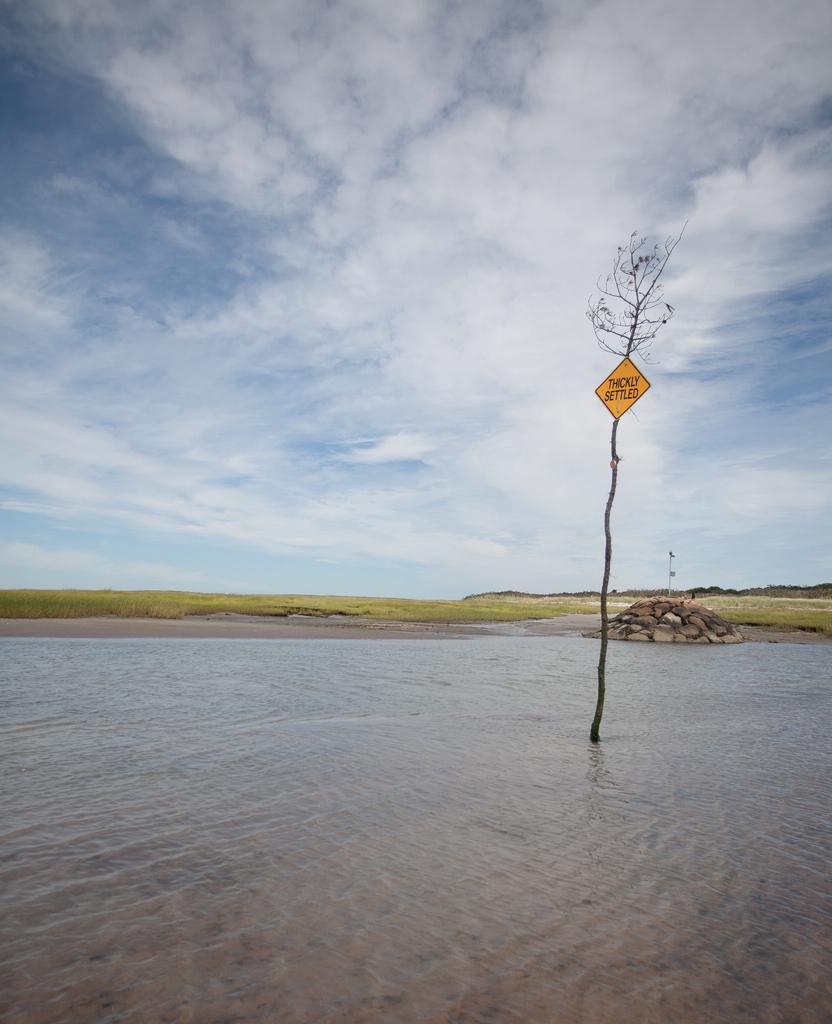Can you describe this image briefly? In this picture we can see a tree with the signboard in the water. Behind the tree there are rocks, grass and the sky. 